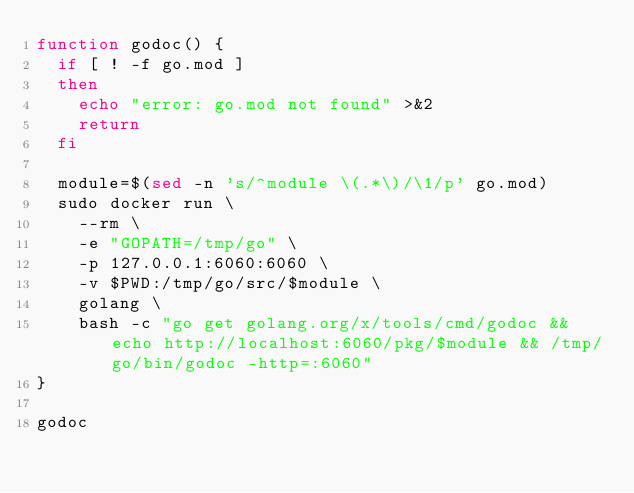Convert code to text. <code><loc_0><loc_0><loc_500><loc_500><_Bash_>function godoc() {
  if [ ! -f go.mod ]
  then
    echo "error: go.mod not found" >&2
    return
  fi

  module=$(sed -n 's/^module \(.*\)/\1/p' go.mod)
  sudo docker run \
    --rm \
    -e "GOPATH=/tmp/go" \
    -p 127.0.0.1:6060:6060 \
    -v $PWD:/tmp/go/src/$module \
    golang \
    bash -c "go get golang.org/x/tools/cmd/godoc && echo http://localhost:6060/pkg/$module && /tmp/go/bin/godoc -http=:6060"
}

godoc
</code> 